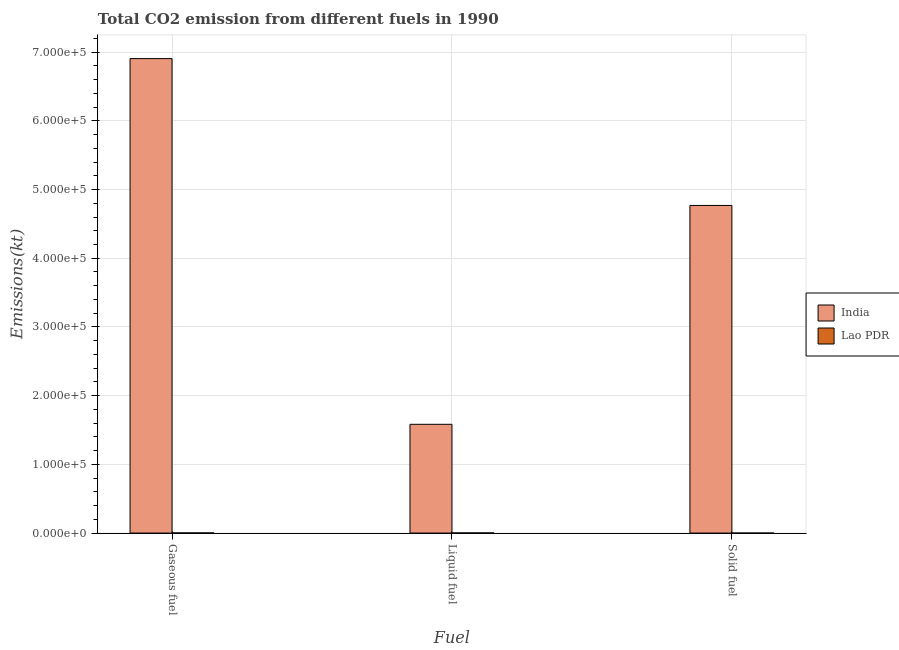How many different coloured bars are there?
Your answer should be very brief. 2. How many bars are there on the 2nd tick from the left?
Your answer should be very brief. 2. What is the label of the 2nd group of bars from the left?
Your answer should be very brief. Liquid fuel. What is the amount of co2 emissions from liquid fuel in Lao PDR?
Your answer should be compact. 231.02. Across all countries, what is the maximum amount of co2 emissions from gaseous fuel?
Keep it short and to the point. 6.91e+05. Across all countries, what is the minimum amount of co2 emissions from liquid fuel?
Your answer should be very brief. 231.02. In which country was the amount of co2 emissions from gaseous fuel maximum?
Provide a succinct answer. India. In which country was the amount of co2 emissions from solid fuel minimum?
Provide a short and direct response. Lao PDR. What is the total amount of co2 emissions from liquid fuel in the graph?
Your response must be concise. 1.59e+05. What is the difference between the amount of co2 emissions from liquid fuel in Lao PDR and that in India?
Your answer should be very brief. -1.58e+05. What is the difference between the amount of co2 emissions from solid fuel in India and the amount of co2 emissions from liquid fuel in Lao PDR?
Your answer should be compact. 4.77e+05. What is the average amount of co2 emissions from liquid fuel per country?
Offer a very short reply. 7.93e+04. What is the difference between the amount of co2 emissions from gaseous fuel and amount of co2 emissions from solid fuel in India?
Offer a very short reply. 2.14e+05. In how many countries, is the amount of co2 emissions from solid fuel greater than 20000 kt?
Make the answer very short. 1. What is the ratio of the amount of co2 emissions from liquid fuel in India to that in Lao PDR?
Give a very brief answer. 685.21. What is the difference between the highest and the second highest amount of co2 emissions from gaseous fuel?
Ensure brevity in your answer.  6.90e+05. What is the difference between the highest and the lowest amount of co2 emissions from solid fuel?
Provide a short and direct response. 4.77e+05. What does the 2nd bar from the left in Solid fuel represents?
Provide a short and direct response. Lao PDR. What does the 1st bar from the right in Solid fuel represents?
Your answer should be compact. Lao PDR. How many countries are there in the graph?
Offer a terse response. 2. What is the difference between two consecutive major ticks on the Y-axis?
Make the answer very short. 1.00e+05. Are the values on the major ticks of Y-axis written in scientific E-notation?
Your answer should be compact. Yes. Does the graph contain any zero values?
Offer a terse response. No. Where does the legend appear in the graph?
Your answer should be compact. Center right. How many legend labels are there?
Make the answer very short. 2. What is the title of the graph?
Give a very brief answer. Total CO2 emission from different fuels in 1990. What is the label or title of the X-axis?
Offer a terse response. Fuel. What is the label or title of the Y-axis?
Keep it short and to the point. Emissions(kt). What is the Emissions(kt) in India in Gaseous fuel?
Provide a succinct answer. 6.91e+05. What is the Emissions(kt) in Lao PDR in Gaseous fuel?
Your answer should be very brief. 234.69. What is the Emissions(kt) in India in Liquid fuel?
Provide a succinct answer. 1.58e+05. What is the Emissions(kt) in Lao PDR in Liquid fuel?
Provide a succinct answer. 231.02. What is the Emissions(kt) in India in Solid fuel?
Your answer should be very brief. 4.77e+05. What is the Emissions(kt) in Lao PDR in Solid fuel?
Offer a very short reply. 3.67. Across all Fuel, what is the maximum Emissions(kt) in India?
Offer a terse response. 6.91e+05. Across all Fuel, what is the maximum Emissions(kt) of Lao PDR?
Offer a very short reply. 234.69. Across all Fuel, what is the minimum Emissions(kt) of India?
Provide a short and direct response. 1.58e+05. Across all Fuel, what is the minimum Emissions(kt) in Lao PDR?
Provide a short and direct response. 3.67. What is the total Emissions(kt) of India in the graph?
Make the answer very short. 1.33e+06. What is the total Emissions(kt) of Lao PDR in the graph?
Provide a succinct answer. 469.38. What is the difference between the Emissions(kt) of India in Gaseous fuel and that in Liquid fuel?
Provide a succinct answer. 5.32e+05. What is the difference between the Emissions(kt) of Lao PDR in Gaseous fuel and that in Liquid fuel?
Offer a very short reply. 3.67. What is the difference between the Emissions(kt) of India in Gaseous fuel and that in Solid fuel?
Offer a terse response. 2.14e+05. What is the difference between the Emissions(kt) in Lao PDR in Gaseous fuel and that in Solid fuel?
Your answer should be very brief. 231.02. What is the difference between the Emissions(kt) in India in Liquid fuel and that in Solid fuel?
Your answer should be compact. -3.19e+05. What is the difference between the Emissions(kt) in Lao PDR in Liquid fuel and that in Solid fuel?
Your answer should be compact. 227.35. What is the difference between the Emissions(kt) of India in Gaseous fuel and the Emissions(kt) of Lao PDR in Liquid fuel?
Your answer should be compact. 6.90e+05. What is the difference between the Emissions(kt) in India in Gaseous fuel and the Emissions(kt) in Lao PDR in Solid fuel?
Your answer should be very brief. 6.91e+05. What is the difference between the Emissions(kt) in India in Liquid fuel and the Emissions(kt) in Lao PDR in Solid fuel?
Give a very brief answer. 1.58e+05. What is the average Emissions(kt) of India per Fuel?
Provide a succinct answer. 4.42e+05. What is the average Emissions(kt) of Lao PDR per Fuel?
Make the answer very short. 156.46. What is the difference between the Emissions(kt) in India and Emissions(kt) in Lao PDR in Gaseous fuel?
Make the answer very short. 6.90e+05. What is the difference between the Emissions(kt) in India and Emissions(kt) in Lao PDR in Liquid fuel?
Your response must be concise. 1.58e+05. What is the difference between the Emissions(kt) of India and Emissions(kt) of Lao PDR in Solid fuel?
Your answer should be compact. 4.77e+05. What is the ratio of the Emissions(kt) in India in Gaseous fuel to that in Liquid fuel?
Your answer should be compact. 4.36. What is the ratio of the Emissions(kt) of Lao PDR in Gaseous fuel to that in Liquid fuel?
Make the answer very short. 1.02. What is the ratio of the Emissions(kt) of India in Gaseous fuel to that in Solid fuel?
Give a very brief answer. 1.45. What is the ratio of the Emissions(kt) of India in Liquid fuel to that in Solid fuel?
Your response must be concise. 0.33. What is the difference between the highest and the second highest Emissions(kt) of India?
Give a very brief answer. 2.14e+05. What is the difference between the highest and the second highest Emissions(kt) of Lao PDR?
Your answer should be very brief. 3.67. What is the difference between the highest and the lowest Emissions(kt) in India?
Offer a terse response. 5.32e+05. What is the difference between the highest and the lowest Emissions(kt) of Lao PDR?
Your response must be concise. 231.02. 